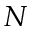Convert formula to latex. <formula><loc_0><loc_0><loc_500><loc_500>N</formula> 